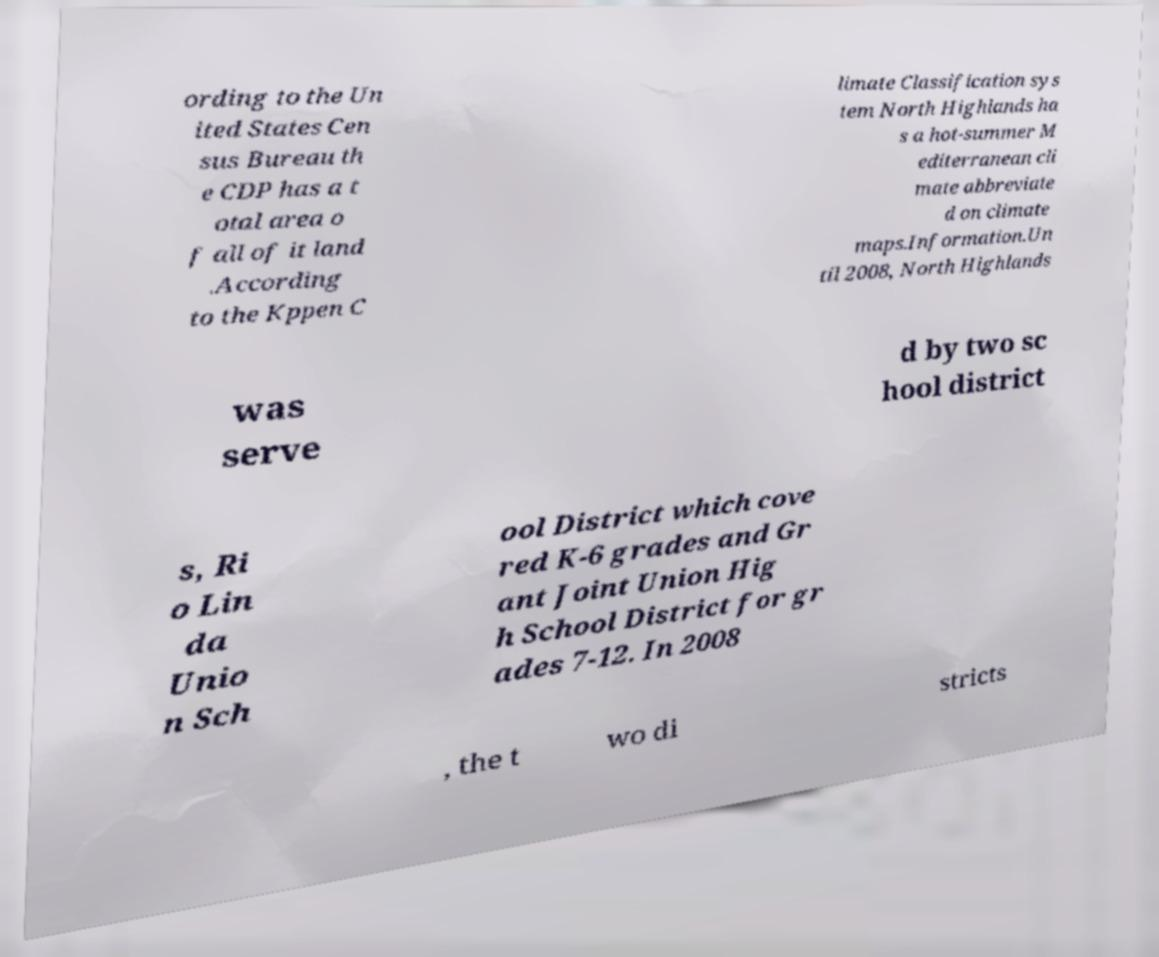Please read and relay the text visible in this image. What does it say? ording to the Un ited States Cen sus Bureau th e CDP has a t otal area o f all of it land .According to the Kppen C limate Classification sys tem North Highlands ha s a hot-summer M editerranean cli mate abbreviate d on climate maps.Information.Un til 2008, North Highlands was serve d by two sc hool district s, Ri o Lin da Unio n Sch ool District which cove red K-6 grades and Gr ant Joint Union Hig h School District for gr ades 7-12. In 2008 , the t wo di stricts 